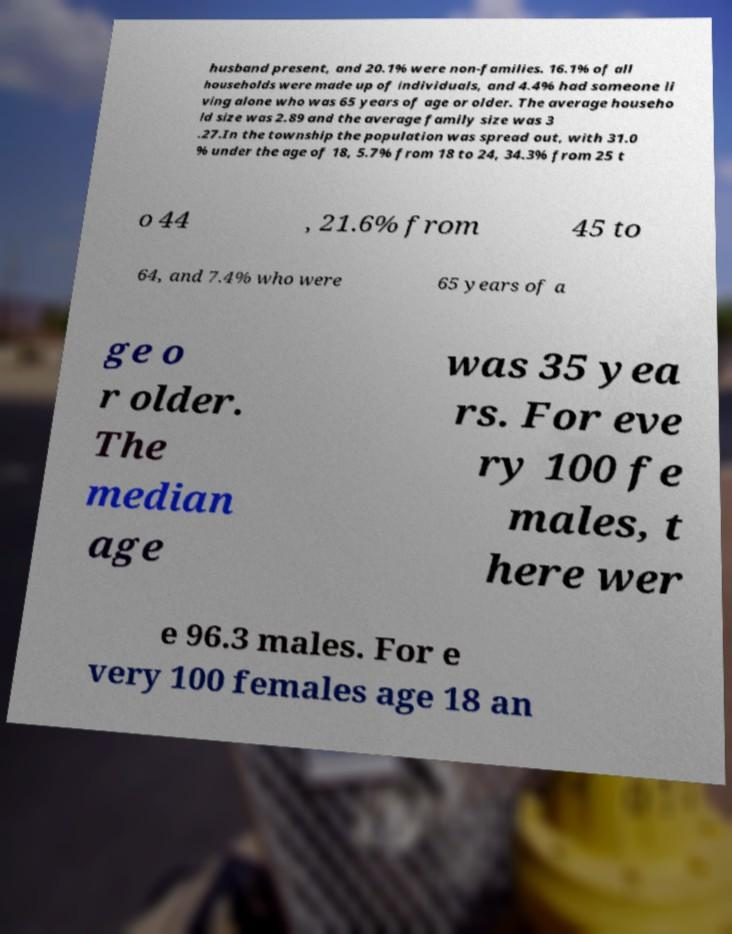Could you extract and type out the text from this image? husband present, and 20.1% were non-families. 16.1% of all households were made up of individuals, and 4.4% had someone li ving alone who was 65 years of age or older. The average househo ld size was 2.89 and the average family size was 3 .27.In the township the population was spread out, with 31.0 % under the age of 18, 5.7% from 18 to 24, 34.3% from 25 t o 44 , 21.6% from 45 to 64, and 7.4% who were 65 years of a ge o r older. The median age was 35 yea rs. For eve ry 100 fe males, t here wer e 96.3 males. For e very 100 females age 18 an 